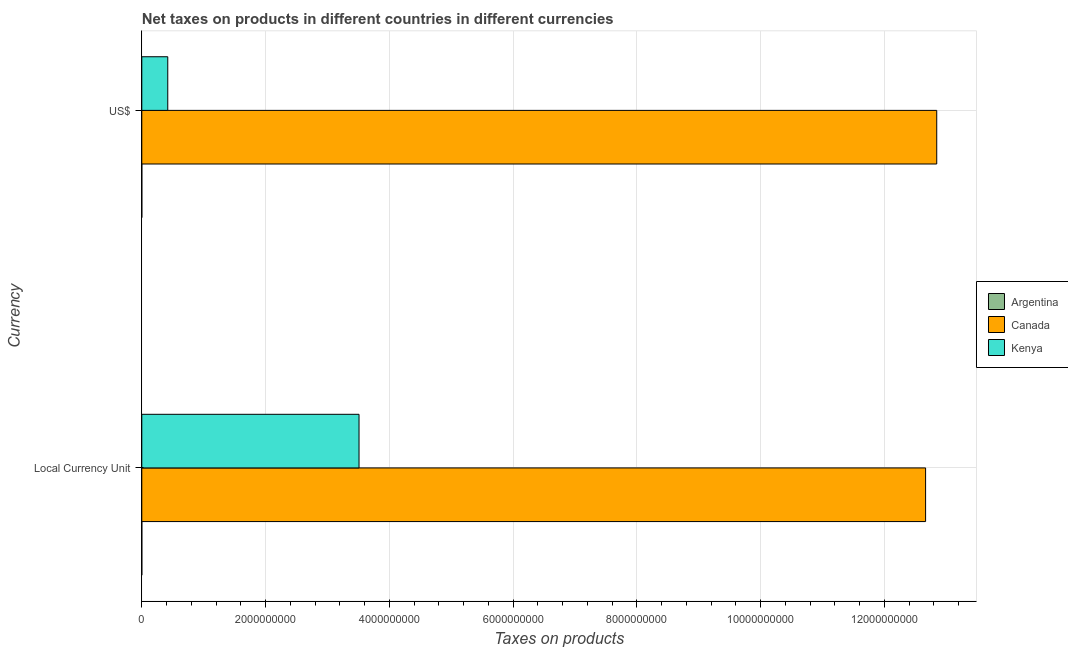How many different coloured bars are there?
Your response must be concise. 3. How many groups of bars are there?
Provide a short and direct response. 2. Are the number of bars on each tick of the Y-axis equal?
Keep it short and to the point. Yes. How many bars are there on the 2nd tick from the top?
Make the answer very short. 3. How many bars are there on the 2nd tick from the bottom?
Provide a succinct answer. 3. What is the label of the 1st group of bars from the top?
Keep it short and to the point. US$. What is the net taxes in constant 2005 us$ in Canada?
Provide a succinct answer. 1.27e+1. Across all countries, what is the maximum net taxes in constant 2005 us$?
Your response must be concise. 1.27e+1. Across all countries, what is the minimum net taxes in constant 2005 us$?
Offer a very short reply. 8.36849e-5. In which country was the net taxes in constant 2005 us$ maximum?
Provide a short and direct response. Canada. In which country was the net taxes in constant 2005 us$ minimum?
Your response must be concise. Argentina. What is the total net taxes in constant 2005 us$ in the graph?
Your answer should be very brief. 1.62e+1. What is the difference between the net taxes in constant 2005 us$ in Argentina and that in Kenya?
Offer a terse response. -3.51e+09. What is the difference between the net taxes in us$ in Canada and the net taxes in constant 2005 us$ in Kenya?
Your answer should be compact. 9.33e+09. What is the average net taxes in constant 2005 us$ per country?
Give a very brief answer. 5.39e+09. What is the difference between the net taxes in us$ and net taxes in constant 2005 us$ in Argentina?
Provide a succinct answer. 4.18e+04. In how many countries, is the net taxes in constant 2005 us$ greater than 12800000000 units?
Provide a succinct answer. 0. What is the ratio of the net taxes in us$ in Kenya to that in Canada?
Keep it short and to the point. 0.03. How many bars are there?
Your answer should be very brief. 6. Are all the bars in the graph horizontal?
Your answer should be very brief. Yes. How many countries are there in the graph?
Ensure brevity in your answer.  3. What is the difference between two consecutive major ticks on the X-axis?
Provide a short and direct response. 2.00e+09. Are the values on the major ticks of X-axis written in scientific E-notation?
Offer a terse response. No. How many legend labels are there?
Your response must be concise. 3. How are the legend labels stacked?
Keep it short and to the point. Vertical. What is the title of the graph?
Give a very brief answer. Net taxes on products in different countries in different currencies. What is the label or title of the X-axis?
Keep it short and to the point. Taxes on products. What is the label or title of the Y-axis?
Offer a terse response. Currency. What is the Taxes on products of Argentina in Local Currency Unit?
Make the answer very short. 8.36849e-5. What is the Taxes on products in Canada in Local Currency Unit?
Keep it short and to the point. 1.27e+1. What is the Taxes on products of Kenya in Local Currency Unit?
Your answer should be compact. 3.51e+09. What is the Taxes on products of Argentina in US$?
Make the answer very short. 4.18e+04. What is the Taxes on products of Canada in US$?
Offer a terse response. 1.28e+1. What is the Taxes on products in Kenya in US$?
Offer a terse response. 4.19e+08. Across all Currency, what is the maximum Taxes on products in Argentina?
Give a very brief answer. 4.18e+04. Across all Currency, what is the maximum Taxes on products in Canada?
Give a very brief answer. 1.28e+1. Across all Currency, what is the maximum Taxes on products in Kenya?
Keep it short and to the point. 3.51e+09. Across all Currency, what is the minimum Taxes on products of Argentina?
Your response must be concise. 8.36849e-5. Across all Currency, what is the minimum Taxes on products in Canada?
Offer a terse response. 1.27e+1. Across all Currency, what is the minimum Taxes on products of Kenya?
Keep it short and to the point. 4.19e+08. What is the total Taxes on products of Argentina in the graph?
Your answer should be very brief. 4.18e+04. What is the total Taxes on products in Canada in the graph?
Your answer should be compact. 2.55e+1. What is the total Taxes on products of Kenya in the graph?
Offer a very short reply. 3.93e+09. What is the difference between the Taxes on products in Argentina in Local Currency Unit and that in US$?
Your answer should be compact. -4.18e+04. What is the difference between the Taxes on products in Canada in Local Currency Unit and that in US$?
Keep it short and to the point. -1.80e+08. What is the difference between the Taxes on products in Kenya in Local Currency Unit and that in US$?
Your answer should be compact. 3.09e+09. What is the difference between the Taxes on products in Argentina in Local Currency Unit and the Taxes on products in Canada in US$?
Your answer should be compact. -1.28e+1. What is the difference between the Taxes on products of Argentina in Local Currency Unit and the Taxes on products of Kenya in US$?
Ensure brevity in your answer.  -4.19e+08. What is the difference between the Taxes on products in Canada in Local Currency Unit and the Taxes on products in Kenya in US$?
Provide a succinct answer. 1.22e+1. What is the average Taxes on products of Argentina per Currency?
Your response must be concise. 2.09e+04. What is the average Taxes on products in Canada per Currency?
Offer a very short reply. 1.28e+1. What is the average Taxes on products of Kenya per Currency?
Give a very brief answer. 1.96e+09. What is the difference between the Taxes on products of Argentina and Taxes on products of Canada in Local Currency Unit?
Offer a terse response. -1.27e+1. What is the difference between the Taxes on products of Argentina and Taxes on products of Kenya in Local Currency Unit?
Ensure brevity in your answer.  -3.51e+09. What is the difference between the Taxes on products in Canada and Taxes on products in Kenya in Local Currency Unit?
Your answer should be very brief. 9.15e+09. What is the difference between the Taxes on products in Argentina and Taxes on products in Canada in US$?
Ensure brevity in your answer.  -1.28e+1. What is the difference between the Taxes on products in Argentina and Taxes on products in Kenya in US$?
Ensure brevity in your answer.  -4.19e+08. What is the difference between the Taxes on products in Canada and Taxes on products in Kenya in US$?
Provide a succinct answer. 1.24e+1. What is the ratio of the Taxes on products of Argentina in Local Currency Unit to that in US$?
Provide a succinct answer. 0. What is the ratio of the Taxes on products of Kenya in Local Currency Unit to that in US$?
Ensure brevity in your answer.  8.37. What is the difference between the highest and the second highest Taxes on products in Argentina?
Provide a short and direct response. 4.18e+04. What is the difference between the highest and the second highest Taxes on products of Canada?
Your response must be concise. 1.80e+08. What is the difference between the highest and the second highest Taxes on products of Kenya?
Provide a succinct answer. 3.09e+09. What is the difference between the highest and the lowest Taxes on products of Argentina?
Your answer should be very brief. 4.18e+04. What is the difference between the highest and the lowest Taxes on products in Canada?
Your answer should be compact. 1.80e+08. What is the difference between the highest and the lowest Taxes on products of Kenya?
Give a very brief answer. 3.09e+09. 